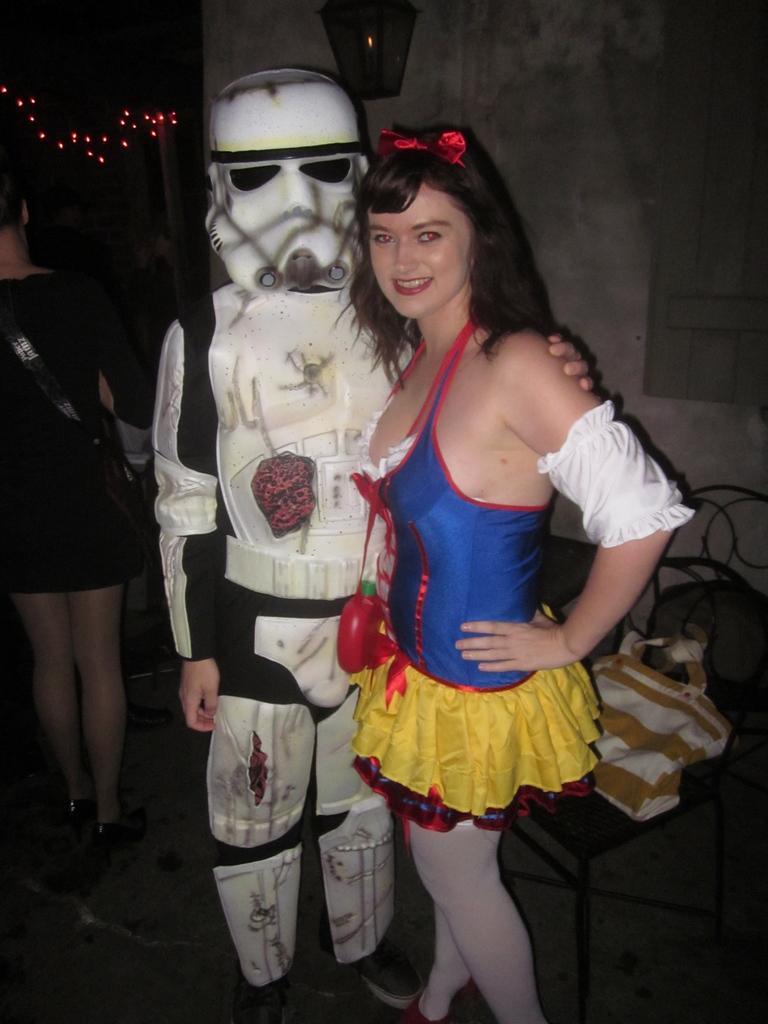In one or two sentences, can you explain what this image depicts? In this image I can see the group of people with different color dresses. I can see one person wearing the costume. To the right I can see a bag on the chair. In the background I can see the lights and the wall. And there is a black background. 